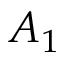<formula> <loc_0><loc_0><loc_500><loc_500>A _ { 1 }</formula> 